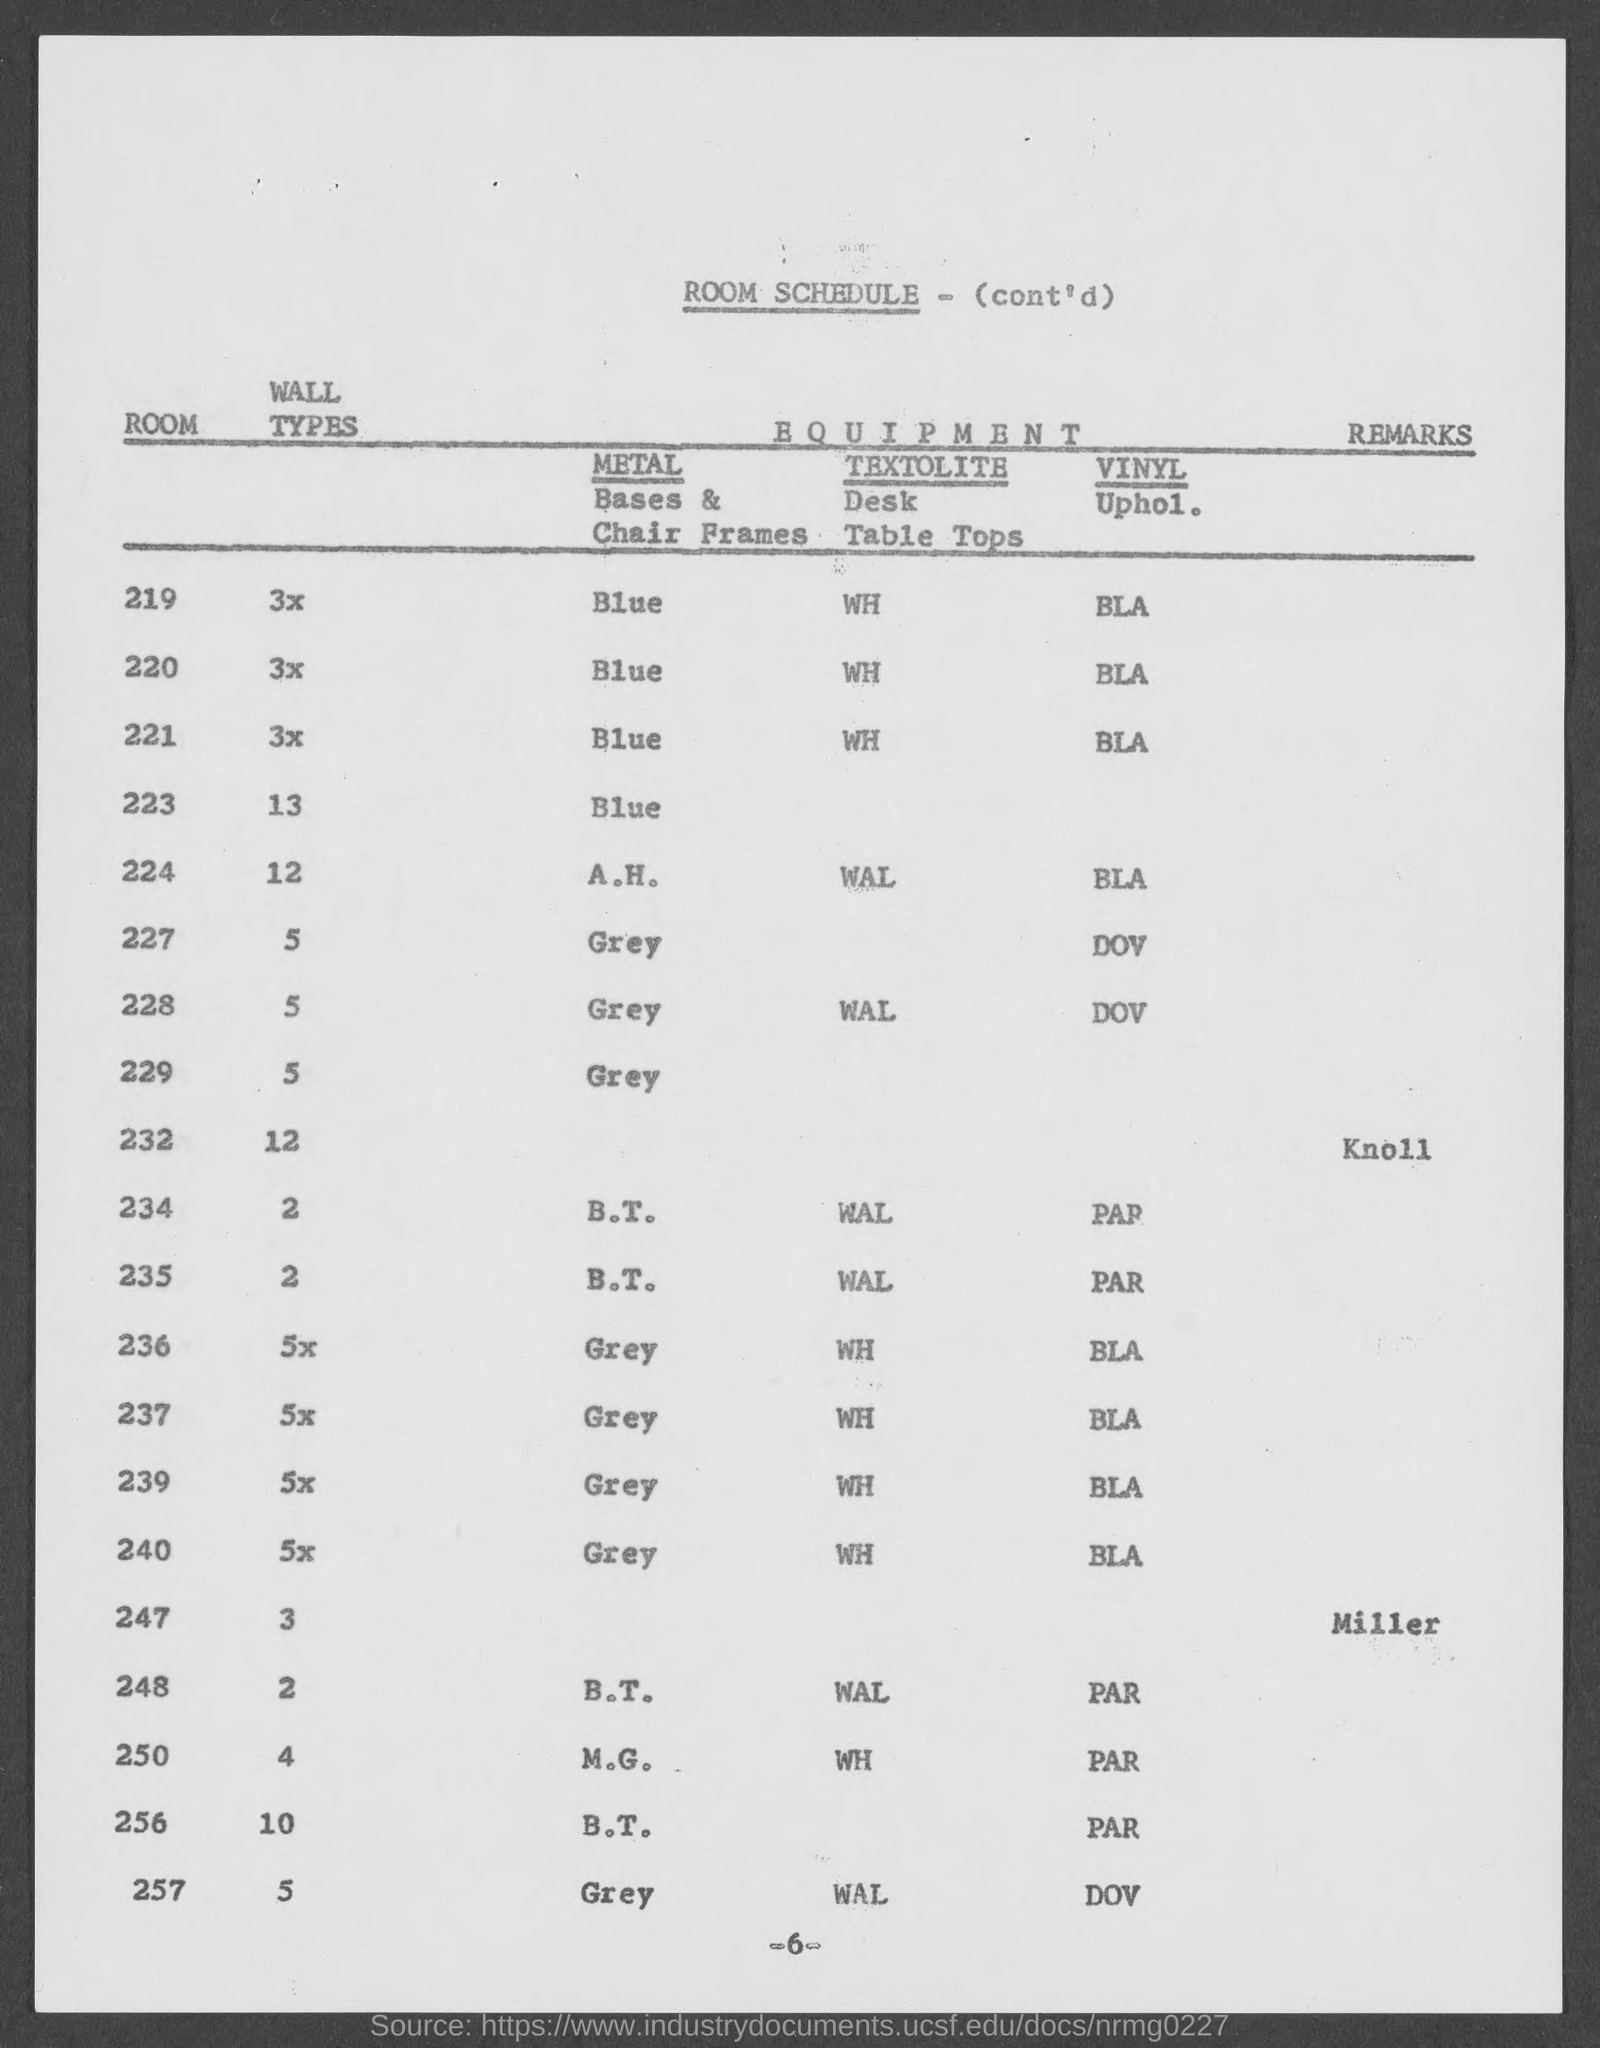What is the title of table?
Provide a short and direct response. Room schedule. 